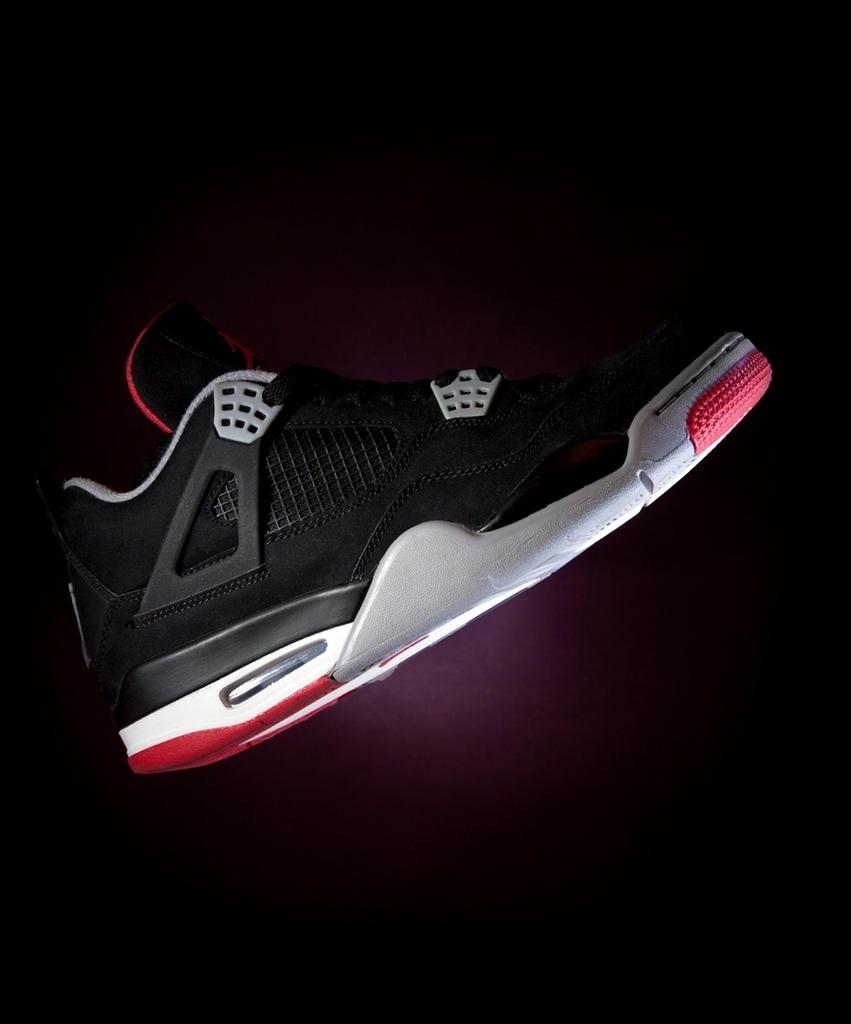What object is the main focus of the image? There is a shoe in the image. What type of feeling does the shoe have towards the fly in the image? There is no fly present in the image, and therefore no interaction between the shoe and a fly can be observed. 